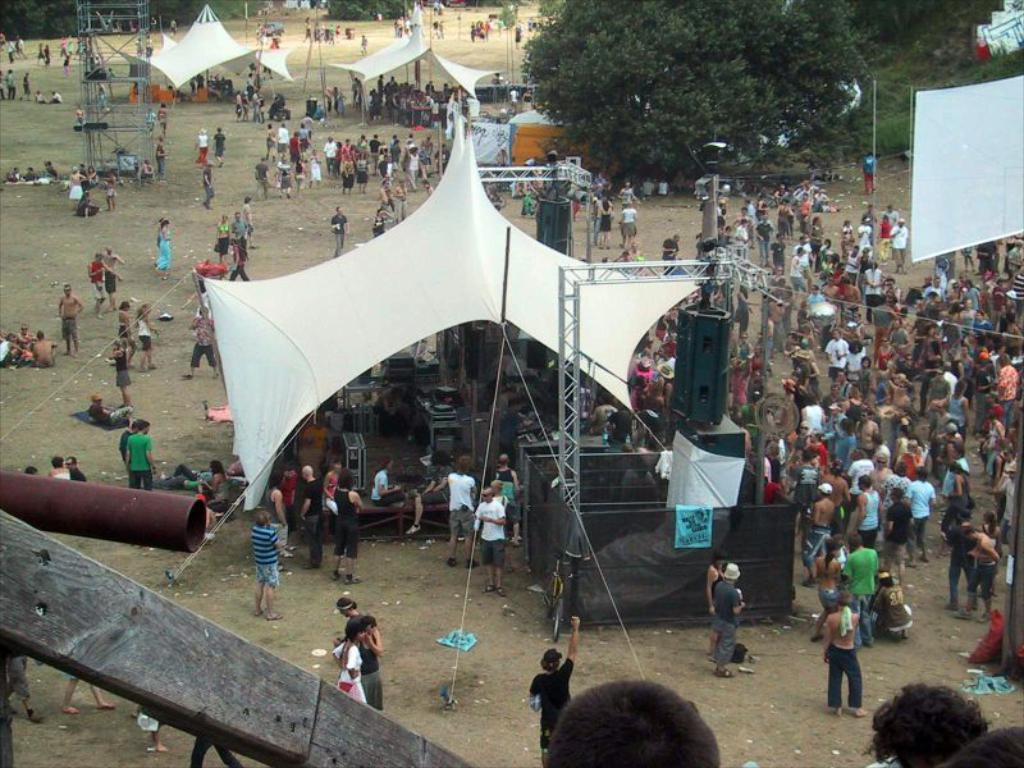How many people are in the image? There is a group of people in the image. Where are the people standing in the image? The people are standing on a path in the image. What can be found on the path besides the people? There are stalls and trees present on the path, as well as other items visible. How does the car get untangled from the knot in the image? There is no car or knot present in the image; it features a group of people standing on a path with stalls and trees. 